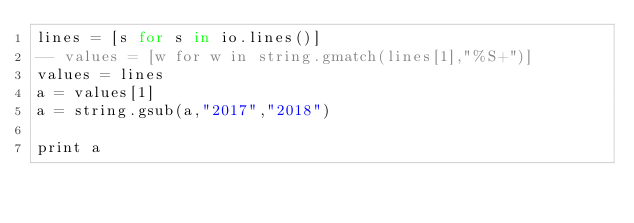Convert code to text. <code><loc_0><loc_0><loc_500><loc_500><_MoonScript_>lines = [s for s in io.lines()]
-- values = [w for w in string.gmatch(lines[1],"%S+")]
values = lines
a = values[1]
a = string.gsub(a,"2017","2018")

print a
</code> 